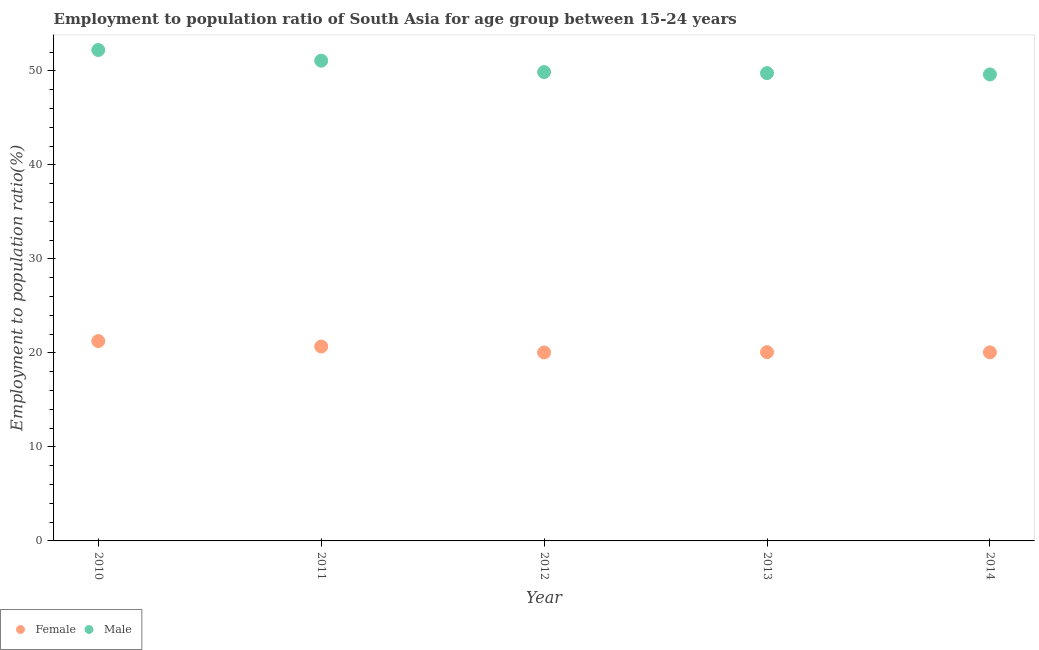Is the number of dotlines equal to the number of legend labels?
Provide a succinct answer. Yes. What is the employment to population ratio(female) in 2011?
Keep it short and to the point. 20.68. Across all years, what is the maximum employment to population ratio(male)?
Provide a short and direct response. 52.22. Across all years, what is the minimum employment to population ratio(female)?
Ensure brevity in your answer.  20.05. In which year was the employment to population ratio(male) maximum?
Your response must be concise. 2010. What is the total employment to population ratio(female) in the graph?
Make the answer very short. 102.13. What is the difference between the employment to population ratio(male) in 2012 and that in 2014?
Give a very brief answer. 0.25. What is the difference between the employment to population ratio(male) in 2011 and the employment to population ratio(female) in 2013?
Keep it short and to the point. 31.01. What is the average employment to population ratio(female) per year?
Provide a succinct answer. 20.43. In the year 2014, what is the difference between the employment to population ratio(male) and employment to population ratio(female)?
Provide a short and direct response. 29.57. In how many years, is the employment to population ratio(male) greater than 12 %?
Provide a succinct answer. 5. What is the ratio of the employment to population ratio(male) in 2010 to that in 2012?
Your answer should be compact. 1.05. What is the difference between the highest and the second highest employment to population ratio(male)?
Provide a succinct answer. 1.14. What is the difference between the highest and the lowest employment to population ratio(male)?
Your answer should be very brief. 2.6. Is the sum of the employment to population ratio(female) in 2011 and 2012 greater than the maximum employment to population ratio(male) across all years?
Give a very brief answer. No. Does the employment to population ratio(male) monotonically increase over the years?
Provide a short and direct response. No. Is the employment to population ratio(female) strictly less than the employment to population ratio(male) over the years?
Your response must be concise. Yes. What is the difference between two consecutive major ticks on the Y-axis?
Make the answer very short. 10. Are the values on the major ticks of Y-axis written in scientific E-notation?
Keep it short and to the point. No. Does the graph contain any zero values?
Your response must be concise. No. Where does the legend appear in the graph?
Your response must be concise. Bottom left. How many legend labels are there?
Your answer should be compact. 2. How are the legend labels stacked?
Ensure brevity in your answer.  Horizontal. What is the title of the graph?
Make the answer very short. Employment to population ratio of South Asia for age group between 15-24 years. Does "Passenger Transport Items" appear as one of the legend labels in the graph?
Provide a succinct answer. No. What is the Employment to population ratio(%) in Female in 2010?
Your answer should be very brief. 21.26. What is the Employment to population ratio(%) of Male in 2010?
Keep it short and to the point. 52.22. What is the Employment to population ratio(%) of Female in 2011?
Your answer should be very brief. 20.68. What is the Employment to population ratio(%) in Male in 2011?
Give a very brief answer. 51.09. What is the Employment to population ratio(%) in Female in 2012?
Your response must be concise. 20.05. What is the Employment to population ratio(%) in Male in 2012?
Provide a succinct answer. 49.88. What is the Employment to population ratio(%) of Female in 2013?
Offer a terse response. 20.08. What is the Employment to population ratio(%) in Male in 2013?
Offer a very short reply. 49.77. What is the Employment to population ratio(%) in Female in 2014?
Offer a terse response. 20.06. What is the Employment to population ratio(%) in Male in 2014?
Your answer should be very brief. 49.62. Across all years, what is the maximum Employment to population ratio(%) of Female?
Ensure brevity in your answer.  21.26. Across all years, what is the maximum Employment to population ratio(%) in Male?
Offer a terse response. 52.22. Across all years, what is the minimum Employment to population ratio(%) of Female?
Your answer should be compact. 20.05. Across all years, what is the minimum Employment to population ratio(%) in Male?
Your answer should be compact. 49.62. What is the total Employment to population ratio(%) of Female in the graph?
Make the answer very short. 102.13. What is the total Employment to population ratio(%) in Male in the graph?
Make the answer very short. 252.58. What is the difference between the Employment to population ratio(%) in Female in 2010 and that in 2011?
Offer a very short reply. 0.58. What is the difference between the Employment to population ratio(%) of Male in 2010 and that in 2011?
Offer a terse response. 1.14. What is the difference between the Employment to population ratio(%) in Female in 2010 and that in 2012?
Give a very brief answer. 1.21. What is the difference between the Employment to population ratio(%) of Male in 2010 and that in 2012?
Ensure brevity in your answer.  2.35. What is the difference between the Employment to population ratio(%) in Female in 2010 and that in 2013?
Your answer should be very brief. 1.18. What is the difference between the Employment to population ratio(%) of Male in 2010 and that in 2013?
Give a very brief answer. 2.46. What is the difference between the Employment to population ratio(%) in Female in 2010 and that in 2014?
Give a very brief answer. 1.2. What is the difference between the Employment to population ratio(%) in Female in 2011 and that in 2012?
Your answer should be compact. 0.63. What is the difference between the Employment to population ratio(%) of Male in 2011 and that in 2012?
Give a very brief answer. 1.21. What is the difference between the Employment to population ratio(%) in Female in 2011 and that in 2013?
Offer a terse response. 0.6. What is the difference between the Employment to population ratio(%) of Male in 2011 and that in 2013?
Your response must be concise. 1.32. What is the difference between the Employment to population ratio(%) in Female in 2011 and that in 2014?
Your answer should be very brief. 0.62. What is the difference between the Employment to population ratio(%) of Male in 2011 and that in 2014?
Your answer should be compact. 1.46. What is the difference between the Employment to population ratio(%) in Female in 2012 and that in 2013?
Your answer should be compact. -0.03. What is the difference between the Employment to population ratio(%) in Male in 2012 and that in 2013?
Your answer should be very brief. 0.11. What is the difference between the Employment to population ratio(%) of Female in 2012 and that in 2014?
Your answer should be compact. -0.01. What is the difference between the Employment to population ratio(%) of Male in 2012 and that in 2014?
Give a very brief answer. 0.25. What is the difference between the Employment to population ratio(%) of Female in 2013 and that in 2014?
Provide a short and direct response. 0.02. What is the difference between the Employment to population ratio(%) of Male in 2013 and that in 2014?
Provide a short and direct response. 0.14. What is the difference between the Employment to population ratio(%) in Female in 2010 and the Employment to population ratio(%) in Male in 2011?
Make the answer very short. -29.83. What is the difference between the Employment to population ratio(%) of Female in 2010 and the Employment to population ratio(%) of Male in 2012?
Make the answer very short. -28.62. What is the difference between the Employment to population ratio(%) in Female in 2010 and the Employment to population ratio(%) in Male in 2013?
Make the answer very short. -28.51. What is the difference between the Employment to population ratio(%) of Female in 2010 and the Employment to population ratio(%) of Male in 2014?
Provide a succinct answer. -28.37. What is the difference between the Employment to population ratio(%) in Female in 2011 and the Employment to population ratio(%) in Male in 2012?
Your response must be concise. -29.19. What is the difference between the Employment to population ratio(%) of Female in 2011 and the Employment to population ratio(%) of Male in 2013?
Your answer should be compact. -29.08. What is the difference between the Employment to population ratio(%) in Female in 2011 and the Employment to population ratio(%) in Male in 2014?
Ensure brevity in your answer.  -28.94. What is the difference between the Employment to population ratio(%) of Female in 2012 and the Employment to population ratio(%) of Male in 2013?
Offer a terse response. -29.72. What is the difference between the Employment to population ratio(%) in Female in 2012 and the Employment to population ratio(%) in Male in 2014?
Provide a short and direct response. -29.58. What is the difference between the Employment to population ratio(%) of Female in 2013 and the Employment to population ratio(%) of Male in 2014?
Your answer should be compact. -29.55. What is the average Employment to population ratio(%) in Female per year?
Provide a short and direct response. 20.43. What is the average Employment to population ratio(%) of Male per year?
Your answer should be compact. 50.52. In the year 2010, what is the difference between the Employment to population ratio(%) in Female and Employment to population ratio(%) in Male?
Offer a terse response. -30.97. In the year 2011, what is the difference between the Employment to population ratio(%) of Female and Employment to population ratio(%) of Male?
Keep it short and to the point. -30.41. In the year 2012, what is the difference between the Employment to population ratio(%) in Female and Employment to population ratio(%) in Male?
Ensure brevity in your answer.  -29.83. In the year 2013, what is the difference between the Employment to population ratio(%) of Female and Employment to population ratio(%) of Male?
Offer a terse response. -29.69. In the year 2014, what is the difference between the Employment to population ratio(%) in Female and Employment to population ratio(%) in Male?
Ensure brevity in your answer.  -29.57. What is the ratio of the Employment to population ratio(%) of Female in 2010 to that in 2011?
Make the answer very short. 1.03. What is the ratio of the Employment to population ratio(%) in Male in 2010 to that in 2011?
Offer a very short reply. 1.02. What is the ratio of the Employment to population ratio(%) of Female in 2010 to that in 2012?
Make the answer very short. 1.06. What is the ratio of the Employment to population ratio(%) of Male in 2010 to that in 2012?
Give a very brief answer. 1.05. What is the ratio of the Employment to population ratio(%) in Female in 2010 to that in 2013?
Give a very brief answer. 1.06. What is the ratio of the Employment to population ratio(%) in Male in 2010 to that in 2013?
Your answer should be compact. 1.05. What is the ratio of the Employment to population ratio(%) of Female in 2010 to that in 2014?
Provide a succinct answer. 1.06. What is the ratio of the Employment to population ratio(%) of Male in 2010 to that in 2014?
Provide a short and direct response. 1.05. What is the ratio of the Employment to population ratio(%) of Female in 2011 to that in 2012?
Provide a short and direct response. 1.03. What is the ratio of the Employment to population ratio(%) in Male in 2011 to that in 2012?
Offer a very short reply. 1.02. What is the ratio of the Employment to population ratio(%) in Female in 2011 to that in 2013?
Keep it short and to the point. 1.03. What is the ratio of the Employment to population ratio(%) of Male in 2011 to that in 2013?
Ensure brevity in your answer.  1.03. What is the ratio of the Employment to population ratio(%) in Female in 2011 to that in 2014?
Keep it short and to the point. 1.03. What is the ratio of the Employment to population ratio(%) of Male in 2011 to that in 2014?
Your answer should be compact. 1.03. What is the ratio of the Employment to population ratio(%) in Female in 2012 to that in 2014?
Ensure brevity in your answer.  1. What is the ratio of the Employment to population ratio(%) in Female in 2013 to that in 2014?
Ensure brevity in your answer.  1. What is the ratio of the Employment to population ratio(%) in Male in 2013 to that in 2014?
Your response must be concise. 1. What is the difference between the highest and the second highest Employment to population ratio(%) of Female?
Provide a short and direct response. 0.58. What is the difference between the highest and the second highest Employment to population ratio(%) of Male?
Keep it short and to the point. 1.14. What is the difference between the highest and the lowest Employment to population ratio(%) of Female?
Your answer should be compact. 1.21. What is the difference between the highest and the lowest Employment to population ratio(%) in Male?
Give a very brief answer. 2.6. 